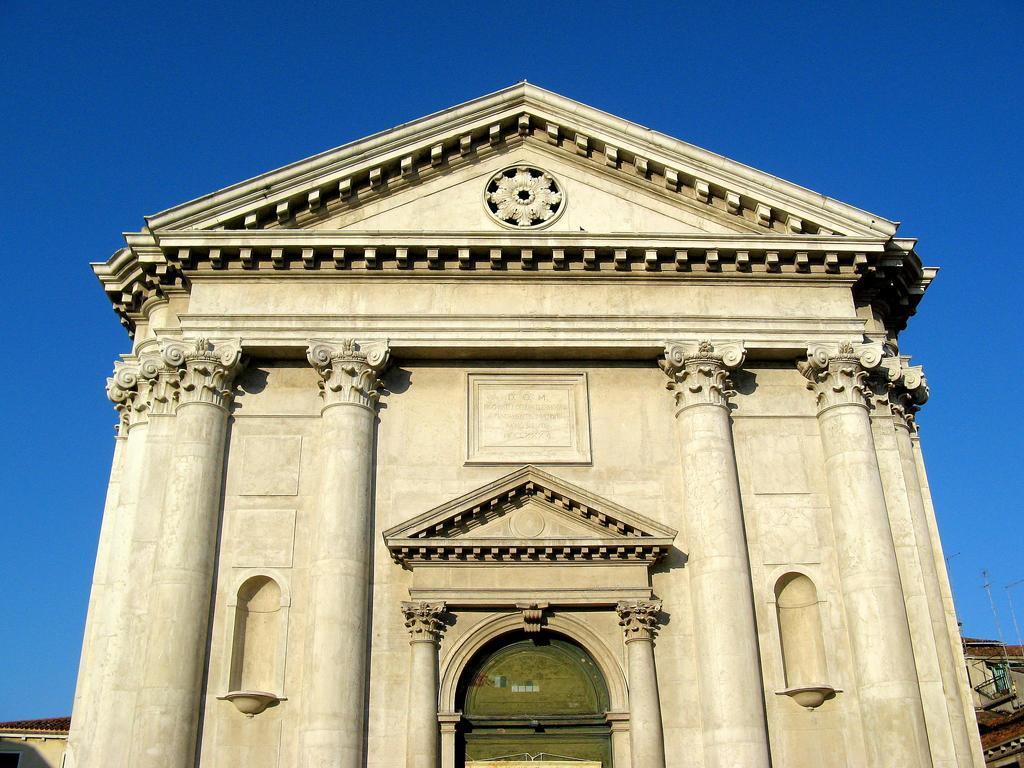Describe this image in one or two sentences. In this image I can see a building and the green colored entrance. In the background I can see few other buildings, few antennas and the sky. 